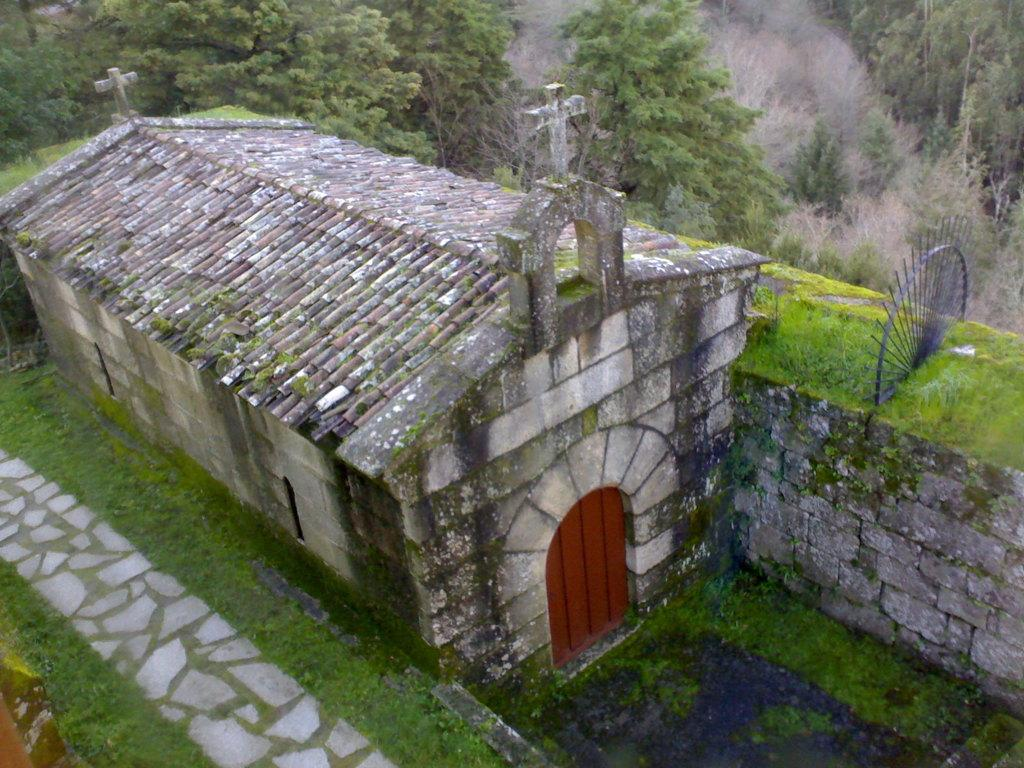What type of building is shown in the image? The image depicts a church. What material appears to be used for the construction of the church? The church appears to be made of stones. What is the color of the door on the church? There is a brown-colored door on the church. What decorative elements can be seen at the top of the church? There are symbols at the top of the church. What type of vegetation is visible behind the church? Trees are visible at the back side of the church. How many legs does the church have in the image? The church does not have legs; it is a building with a foundation. 